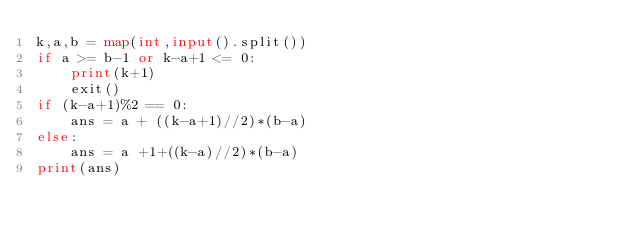Convert code to text. <code><loc_0><loc_0><loc_500><loc_500><_Python_>k,a,b = map(int,input().split())
if a >= b-1 or k-a+1 <= 0:
    print(k+1)
    exit()
if (k-a+1)%2 == 0:
    ans = a + ((k-a+1)//2)*(b-a)
else:
    ans = a +1+((k-a)//2)*(b-a)
print(ans)</code> 